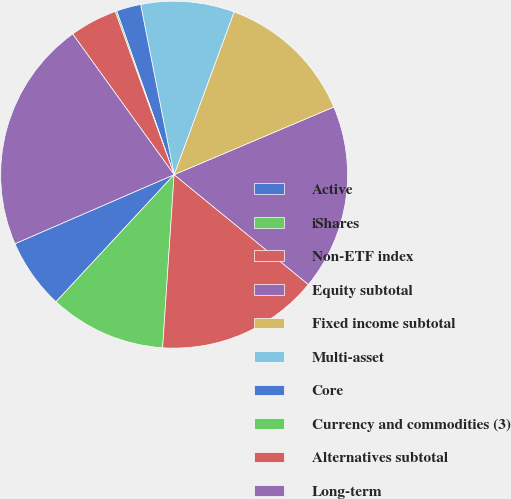Convert chart. <chart><loc_0><loc_0><loc_500><loc_500><pie_chart><fcel>Active<fcel>iShares<fcel>Non-ETF index<fcel>Equity subtotal<fcel>Fixed income subtotal<fcel>Multi-asset<fcel>Core<fcel>Currency and commodities (3)<fcel>Alternatives subtotal<fcel>Long-term<nl><fcel>6.57%<fcel>10.86%<fcel>15.14%<fcel>17.29%<fcel>13.0%<fcel>8.71%<fcel>2.28%<fcel>0.14%<fcel>4.43%<fcel>21.57%<nl></chart> 